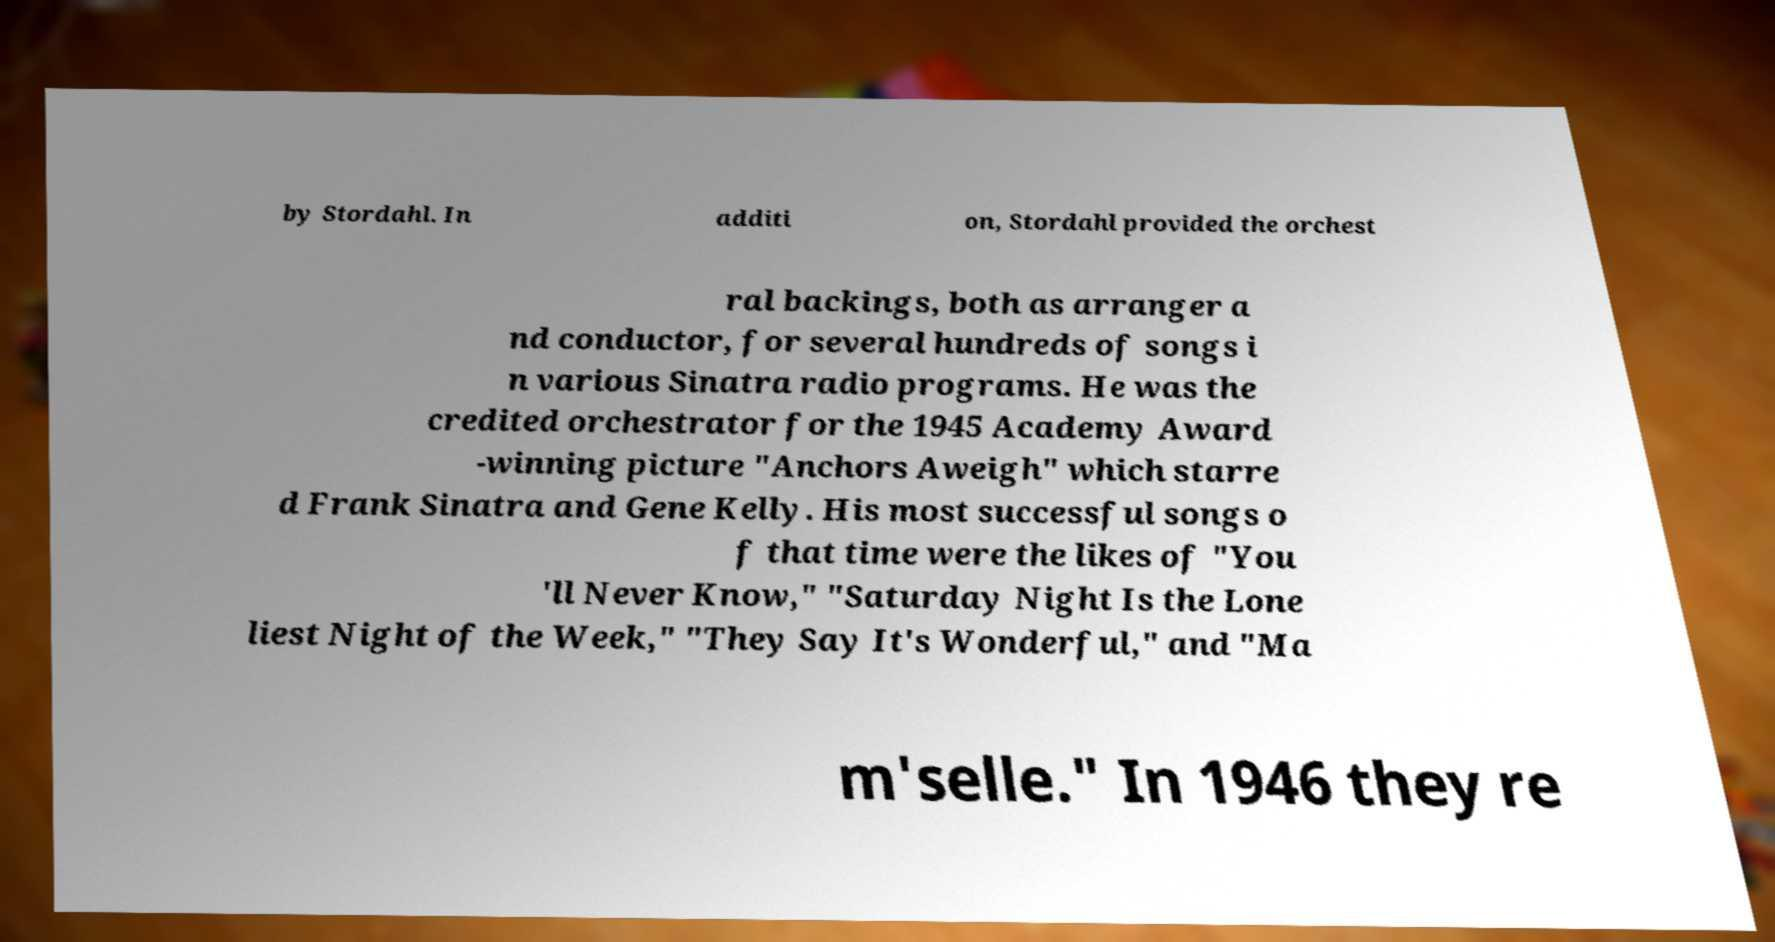Can you read and provide the text displayed in the image?This photo seems to have some interesting text. Can you extract and type it out for me? by Stordahl. In additi on, Stordahl provided the orchest ral backings, both as arranger a nd conductor, for several hundreds of songs i n various Sinatra radio programs. He was the credited orchestrator for the 1945 Academy Award -winning picture "Anchors Aweigh" which starre d Frank Sinatra and Gene Kelly. His most successful songs o f that time were the likes of "You 'll Never Know," "Saturday Night Is the Lone liest Night of the Week," "They Say It's Wonderful," and "Ma m'selle." In 1946 they re 